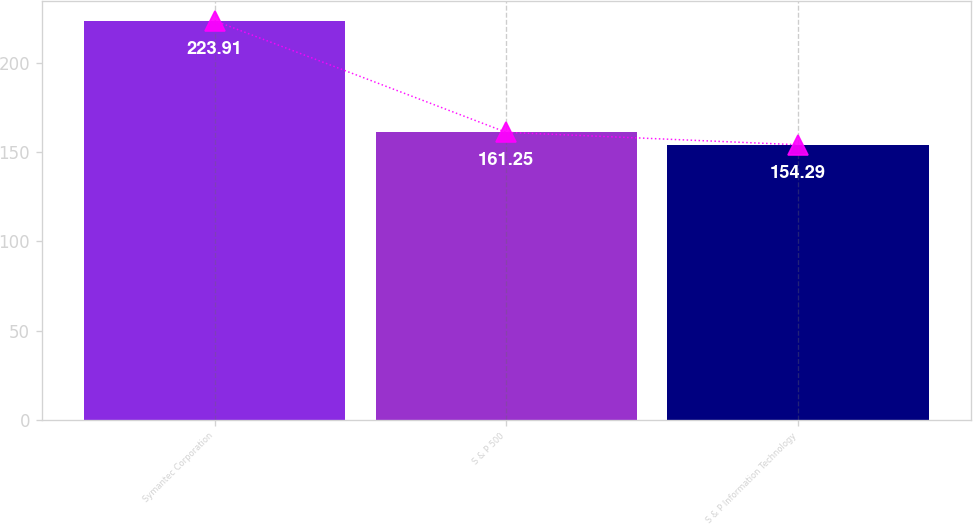<chart> <loc_0><loc_0><loc_500><loc_500><bar_chart><fcel>Symantec Corporation<fcel>S & P 500<fcel>S & P Information Technology<nl><fcel>223.91<fcel>161.25<fcel>154.29<nl></chart> 